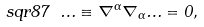Convert formula to latex. <formula><loc_0><loc_0><loc_500><loc_500>\ s q r 8 7 \ \Phi \equiv \nabla ^ { \alpha } \nabla _ { \alpha } \Phi = 0 ,</formula> 